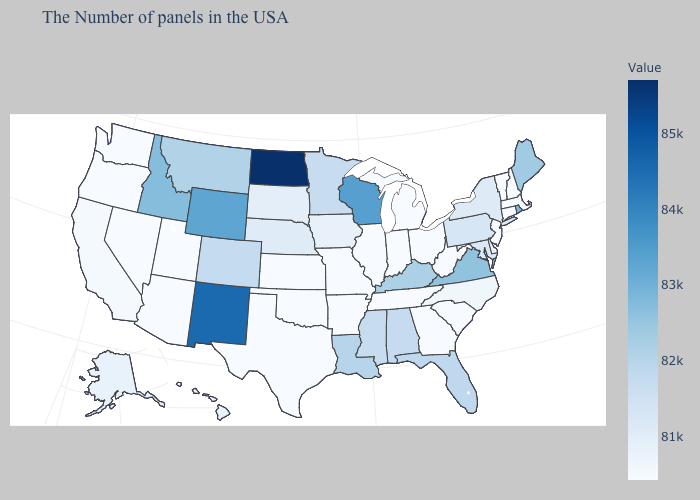Which states hav the highest value in the South?
Give a very brief answer. Virginia. Among the states that border Ohio , does Indiana have the highest value?
Quick response, please. No. Does the map have missing data?
Give a very brief answer. No. Which states hav the highest value in the MidWest?
Give a very brief answer. North Dakota. Among the states that border Idaho , which have the highest value?
Keep it brief. Wyoming. Which states have the lowest value in the USA?
Answer briefly. Massachusetts, New Hampshire, Vermont, Connecticut, New Jersey, South Carolina, West Virginia, Ohio, Georgia, Michigan, Indiana, Tennessee, Illinois, Missouri, Arkansas, Kansas, Oklahoma, Texas, Utah, Arizona, Nevada, Washington, Oregon. 